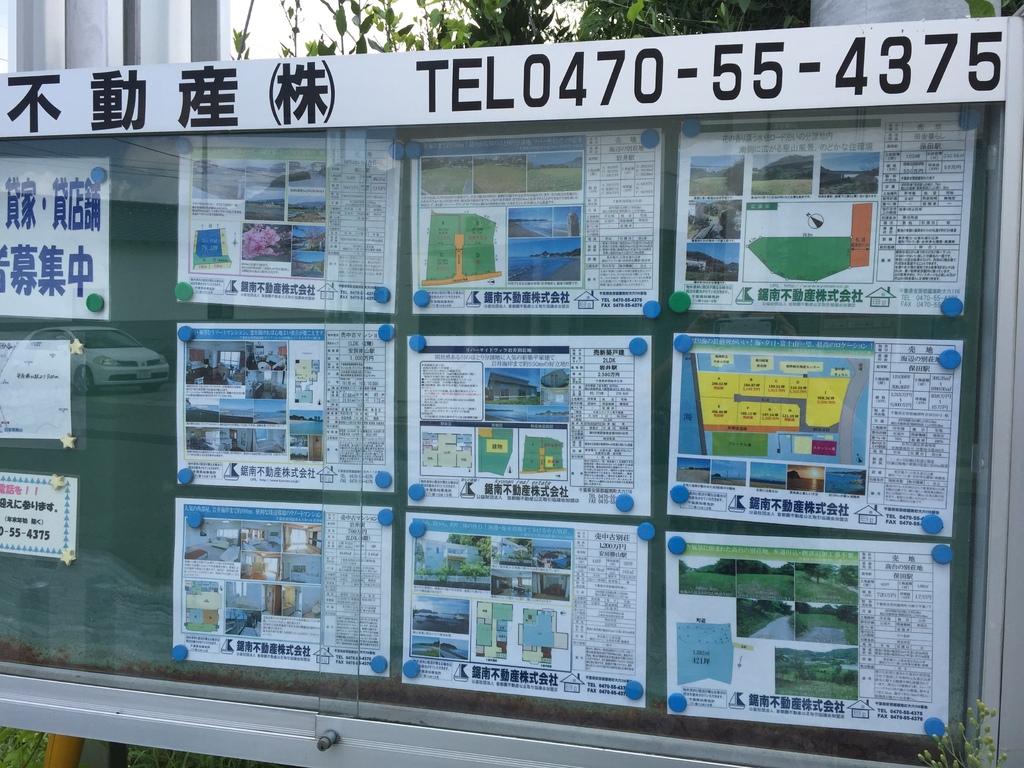What is the telephone number?
Your response must be concise. 0470-55-4375. 